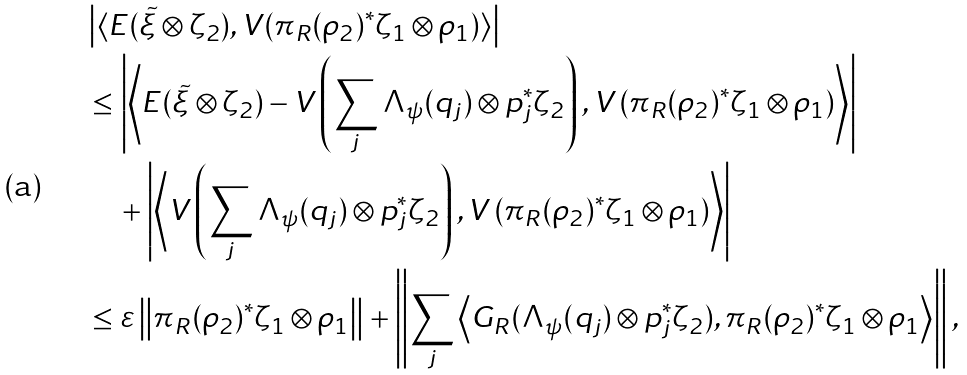<formula> <loc_0><loc_0><loc_500><loc_500>& \left | \langle E ( \tilde { \xi } \otimes \zeta _ { 2 } ) , V ( \pi _ { R } ( \rho _ { 2 } ) ^ { * } \zeta _ { 1 } \otimes \rho _ { 1 } ) \rangle \right | \\ & \leq \left | \left \langle E ( \tilde { \xi } \otimes \zeta _ { 2 } ) - V \left ( \sum _ { j } \Lambda _ { \psi } ( q _ { j } ) \otimes p _ { j } ^ { * } \zeta _ { 2 } \right ) , V \left ( \pi _ { R } ( \rho _ { 2 } ) ^ { * } \zeta _ { 1 } \otimes \rho _ { 1 } \right ) \right \rangle \right | \\ & \quad + \left | \left \langle V \left ( \sum _ { j } \Lambda _ { \psi } ( q _ { j } ) \otimes p _ { j } ^ { * } \zeta _ { 2 } \right ) , V \left ( \pi _ { R } ( \rho _ { 2 } ) ^ { * } \zeta _ { 1 } \otimes \rho _ { 1 } \right ) \right \rangle \right | \\ & \leq \varepsilon \left \| \pi _ { R } ( \rho _ { 2 } ) ^ { * } \zeta _ { 1 } \otimes \rho _ { 1 } \right \| + \left \| \sum _ { j } \left \langle G _ { R } ( \Lambda _ { \psi } ( q _ { j } ) \otimes p _ { j } ^ { * } \zeta _ { 2 } ) , \pi _ { R } ( \rho _ { 2 } ) ^ { * } \zeta _ { 1 } \otimes \rho _ { 1 } \right \rangle \right \| ,</formula> 